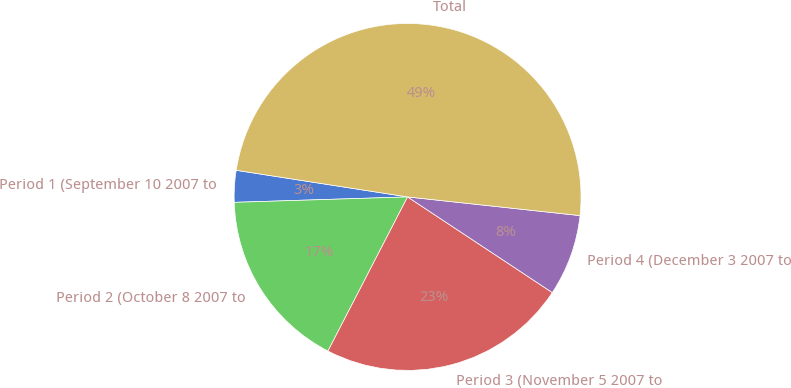Convert chart. <chart><loc_0><loc_0><loc_500><loc_500><pie_chart><fcel>Period 1 (September 10 2007 to<fcel>Period 2 (October 8 2007 to<fcel>Period 3 (November 5 2007 to<fcel>Period 4 (December 3 2007 to<fcel>Total<nl><fcel>2.95%<fcel>16.91%<fcel>23.29%<fcel>7.58%<fcel>49.26%<nl></chart> 